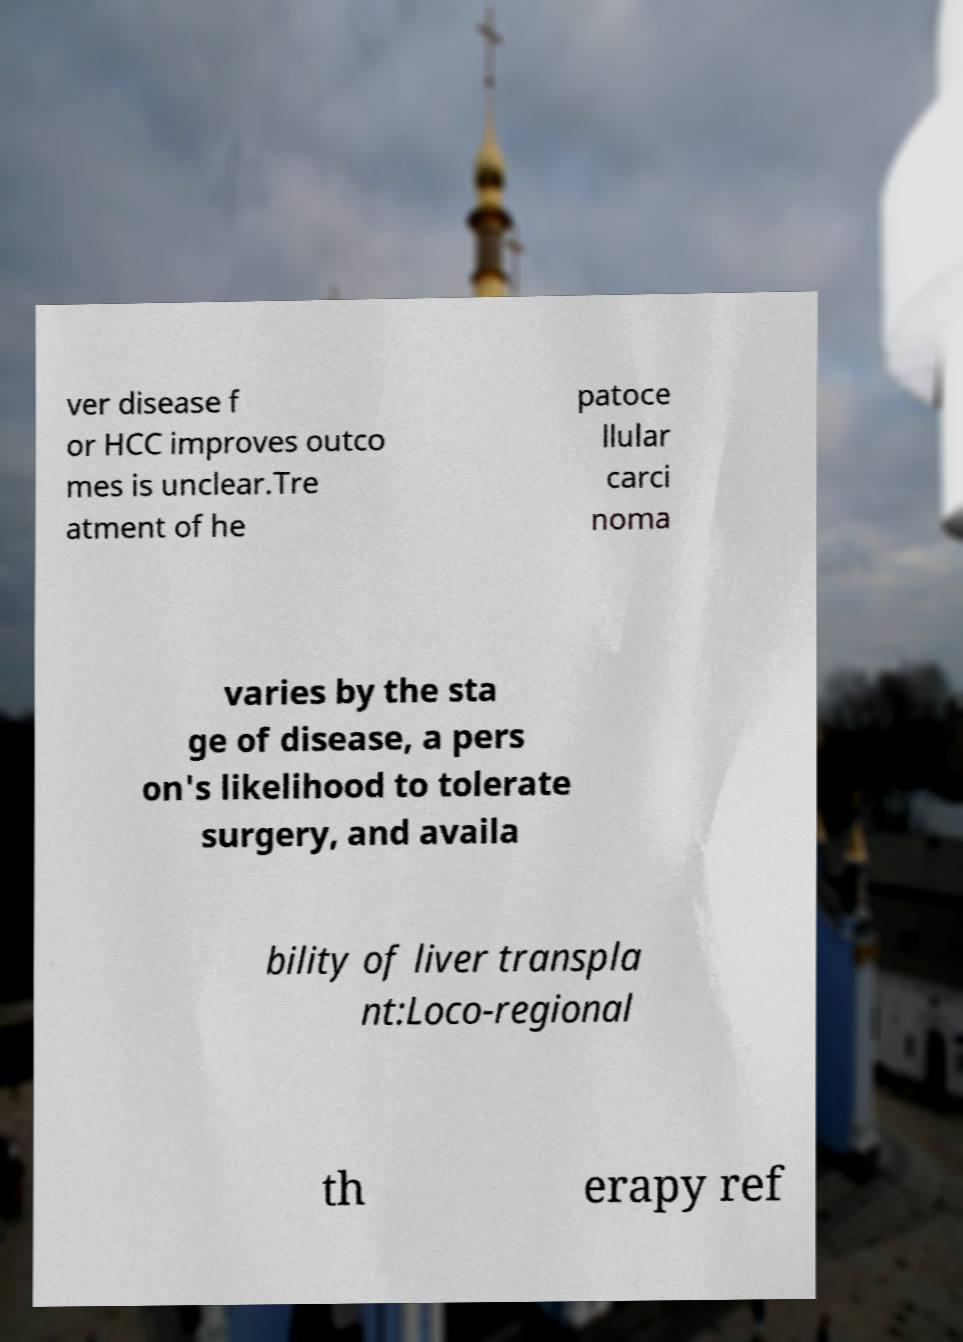Please identify and transcribe the text found in this image. ver disease f or HCC improves outco mes is unclear.Tre atment of he patoce llular carci noma varies by the sta ge of disease, a pers on's likelihood to tolerate surgery, and availa bility of liver transpla nt:Loco-regional th erapy ref 